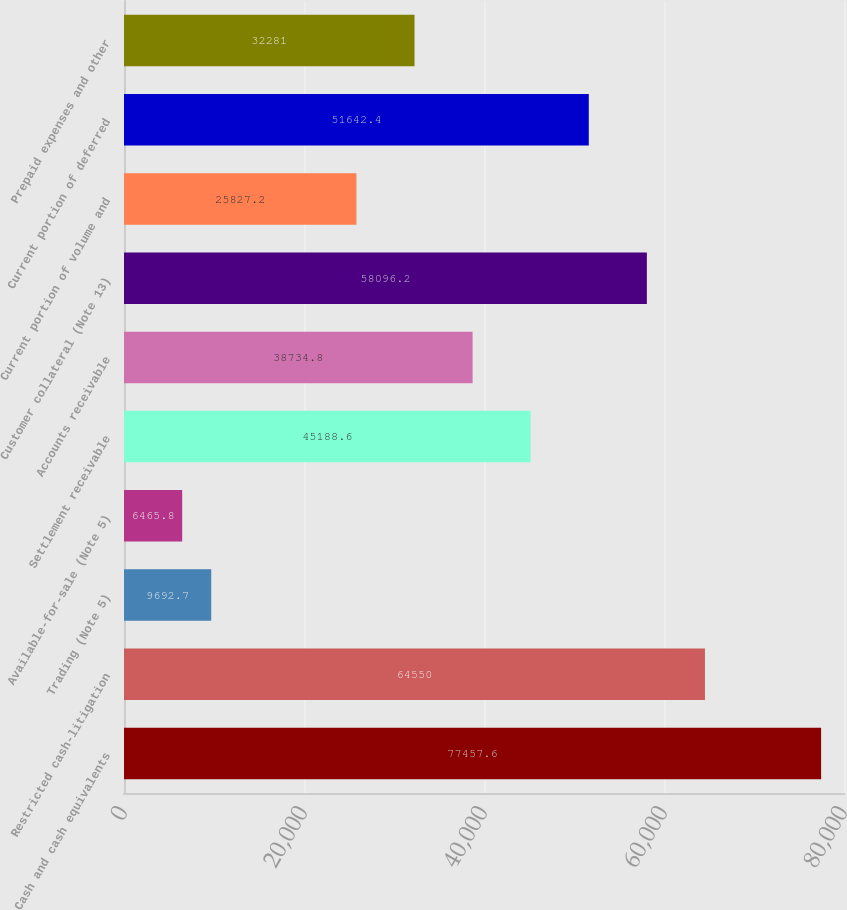<chart> <loc_0><loc_0><loc_500><loc_500><bar_chart><fcel>Cash and cash equivalents<fcel>Restricted cash-litigation<fcel>Trading (Note 5)<fcel>Available-for-sale (Note 5)<fcel>Settlement receivable<fcel>Accounts receivable<fcel>Customer collateral (Note 13)<fcel>Current portion of volume and<fcel>Current portion of deferred<fcel>Prepaid expenses and other<nl><fcel>77457.6<fcel>64550<fcel>9692.7<fcel>6465.8<fcel>45188.6<fcel>38734.8<fcel>58096.2<fcel>25827.2<fcel>51642.4<fcel>32281<nl></chart> 